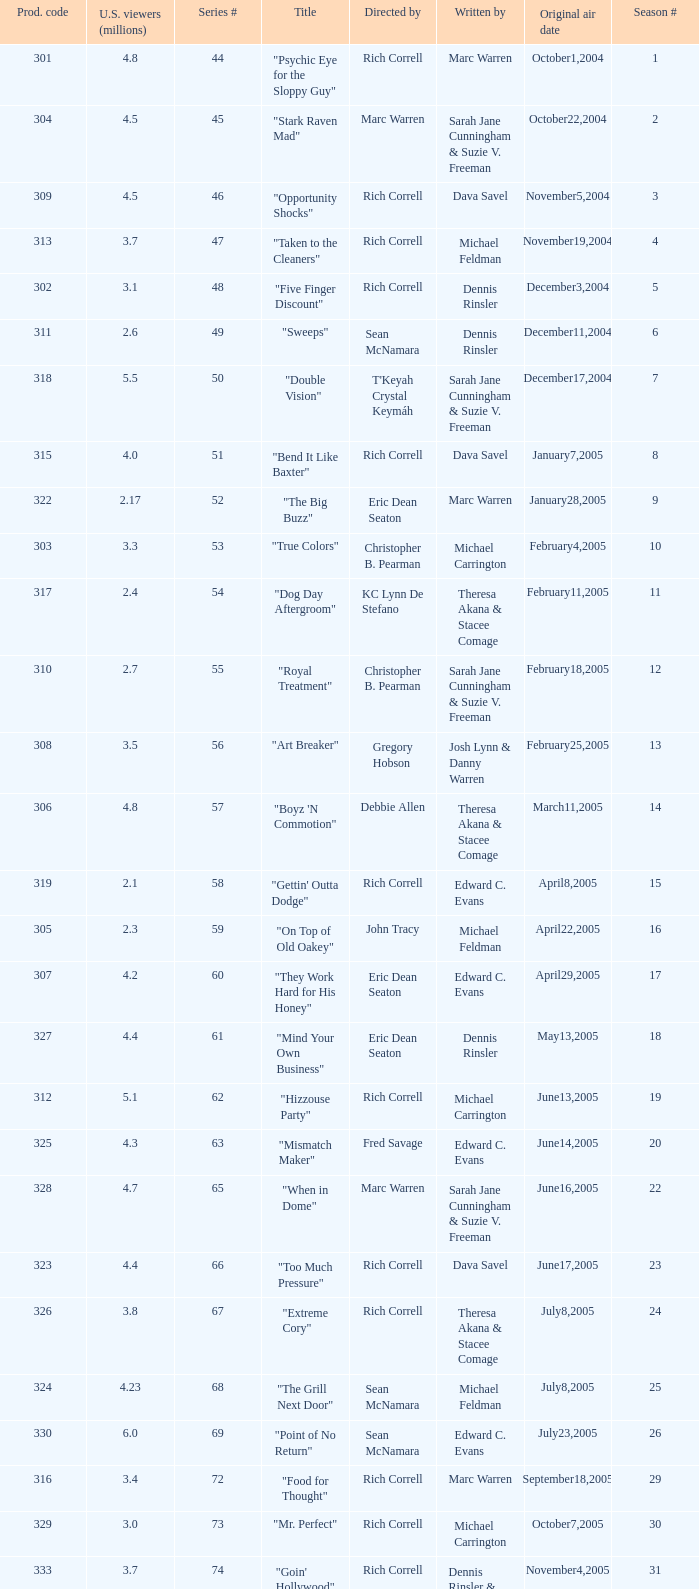What was the production code of the episode directed by Rondell Sheridan?  332.0. 